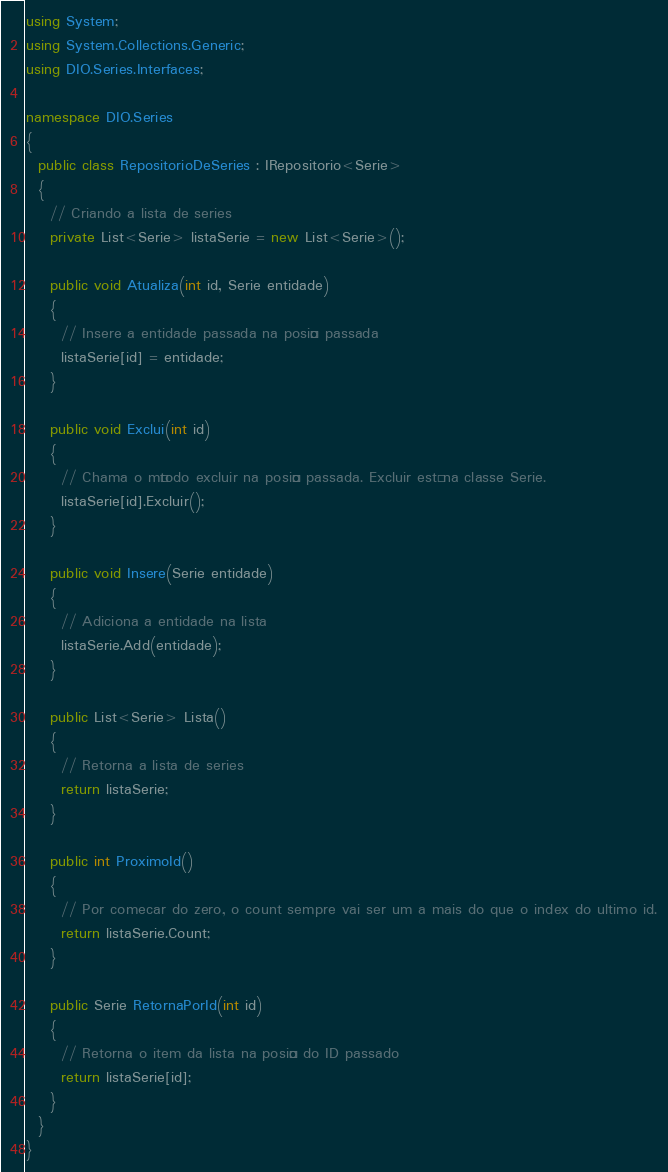<code> <loc_0><loc_0><loc_500><loc_500><_C#_>using System;
using System.Collections.Generic;
using DIO.Series.Interfaces;

namespace DIO.Series
{
  public class RepositorioDeSeries : IRepositorio<Serie>
  {
    // Criando a lista de series
    private List<Serie> listaSerie = new List<Serie>();

    public void Atualiza(int id, Serie entidade)
    {
      // Insere a entidade passada na posição passada
      listaSerie[id] = entidade;
    }

    public void Exclui(int id)
    {
      // Chama o método excluir na posição passada. Excluir está na classe Serie.
      listaSerie[id].Excluir();
    }

    public void Insere(Serie entidade)
    {
      // Adiciona a entidade na lista
      listaSerie.Add(entidade);
    }

    public List<Serie> Lista()
    {
      // Retorna a lista de series
      return listaSerie;
    }

    public int ProximoId()
    {
      // Por comecar do zero, o count sempre vai ser um a mais do que o index do ultimo id.
      return listaSerie.Count;
    }

    public Serie RetornaPorId(int id)
    {
      // Retorna o item da lista na posição do ID passado
      return listaSerie[id];
    }
  }
}</code> 